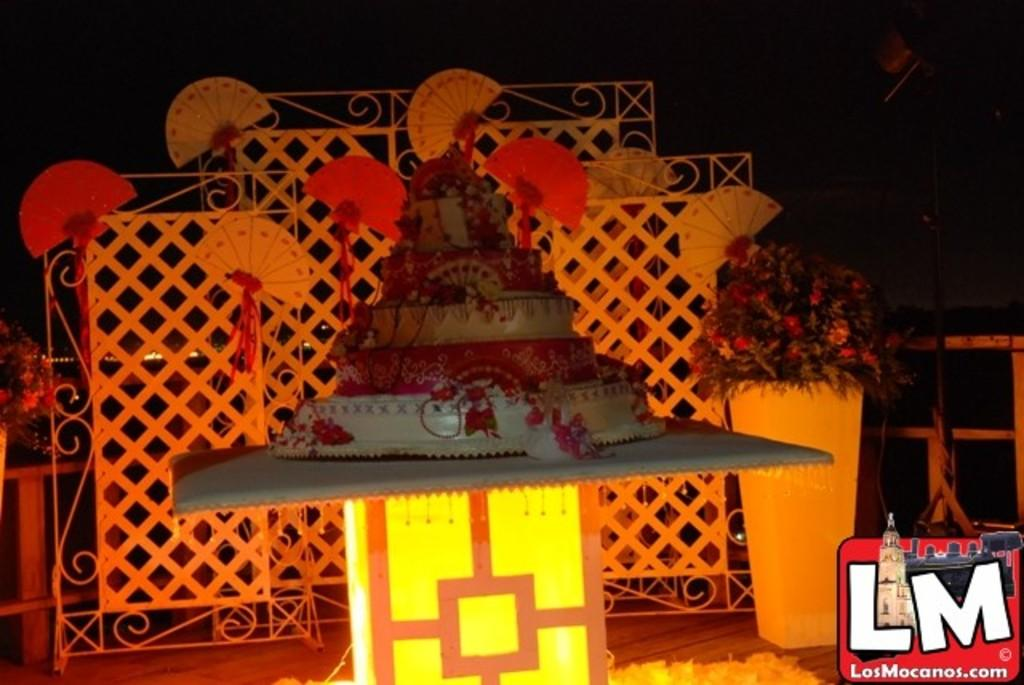What is the main subject of the image? There is a cake in the image. Where is the cake placed? The cake is kept on a surface. What other objects can be seen in the image? There are grills and flowers visible in the image. How would you describe the background of the image? The background of the image is dark. Can you see any feathers on the cake in the image? There are no feathers present on the cake in the image. Is there a ghost visible in the image? There is no ghost present in the image. 